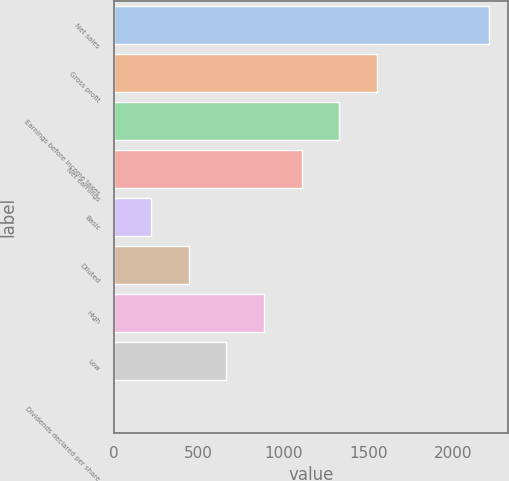Convert chart. <chart><loc_0><loc_0><loc_500><loc_500><bar_chart><fcel>Net sales<fcel>Gross profit<fcel>Earnings before income taxes<fcel>Net earnings<fcel>Basic<fcel>Diluted<fcel>High<fcel>Low<fcel>Dividends declared per share<nl><fcel>2212<fcel>1548.46<fcel>1327.29<fcel>1106.12<fcel>221.44<fcel>442.61<fcel>884.95<fcel>663.78<fcel>0.27<nl></chart> 